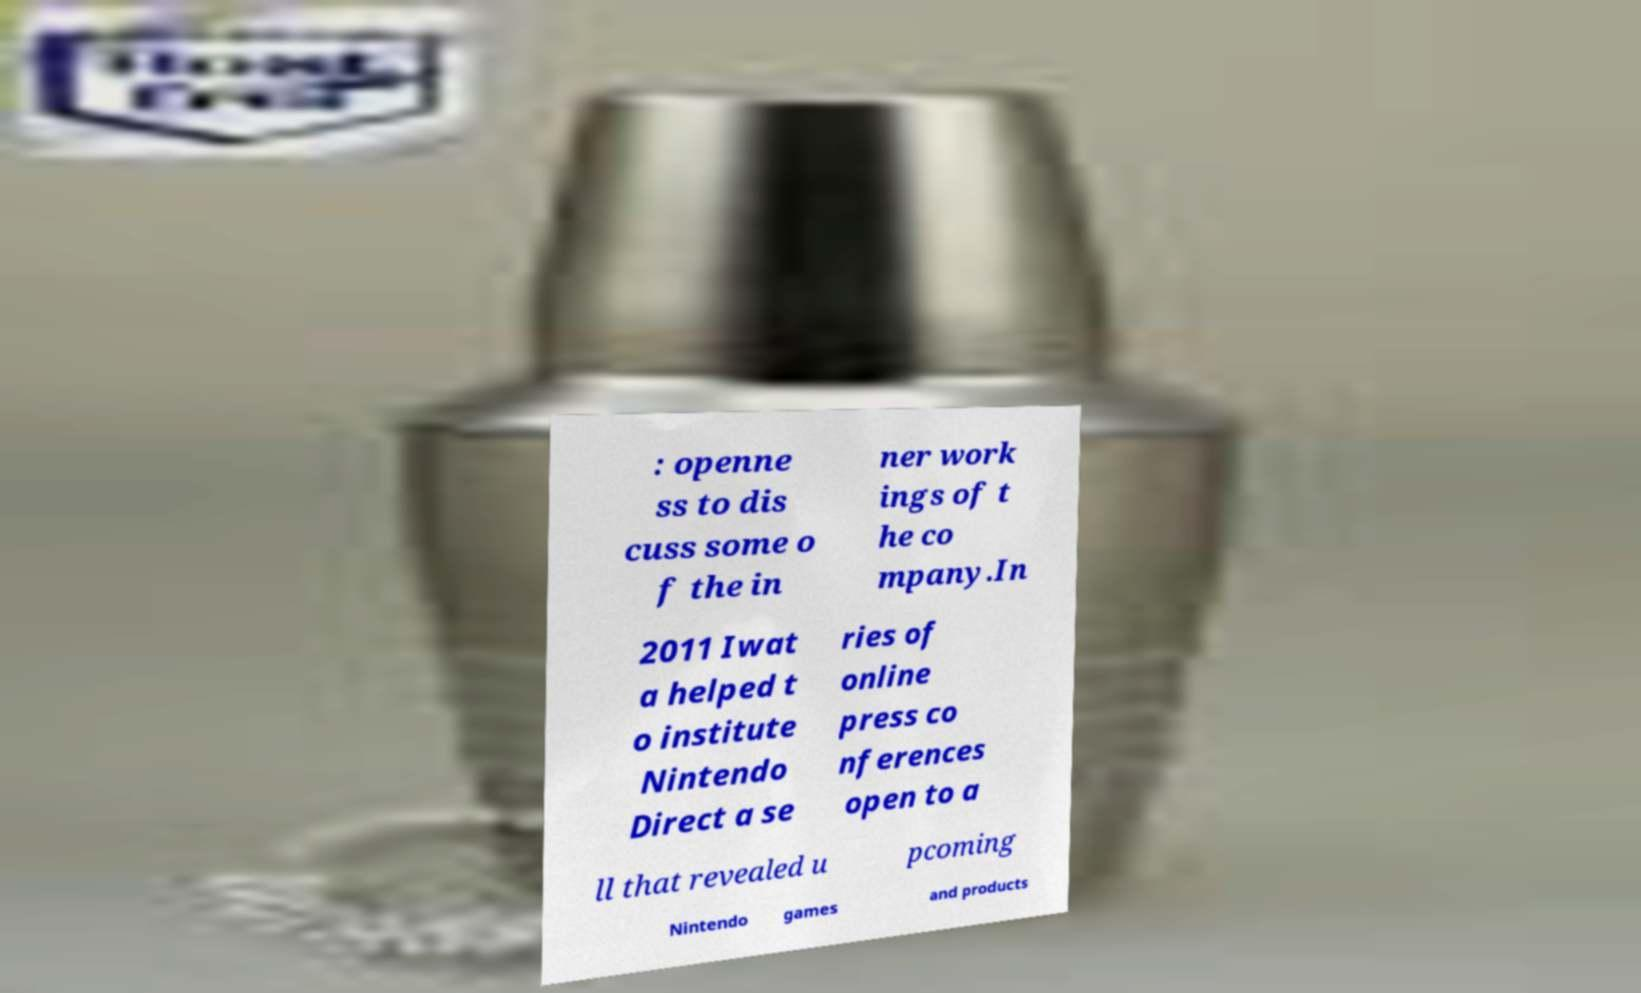Please read and relay the text visible in this image. What does it say? : openne ss to dis cuss some o f the in ner work ings of t he co mpany.In 2011 Iwat a helped t o institute Nintendo Direct a se ries of online press co nferences open to a ll that revealed u pcoming Nintendo games and products 